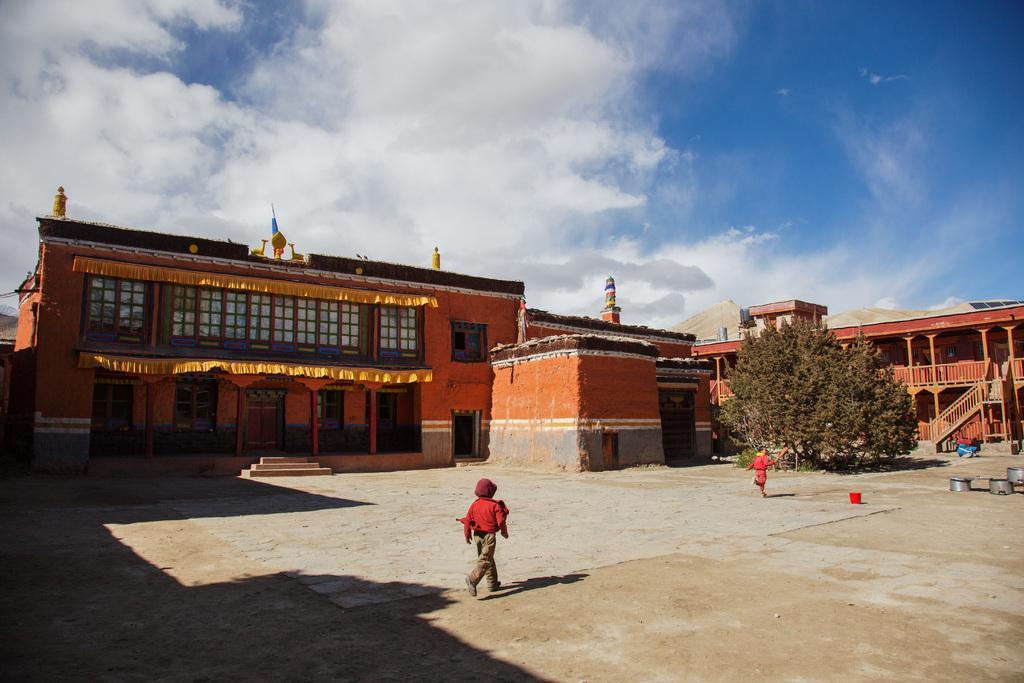How would you summarize this image in a sentence or two? In this picture there is a boy who is wearing cap, t-shirt, jeans and shoe. He is standing on the ground. In the background we can see the buildings. On the right we can see the trees near to the stairs. Beside that there is a girl who is running. At the top we can see sky and clouds. At the top of the building there is a flag. 